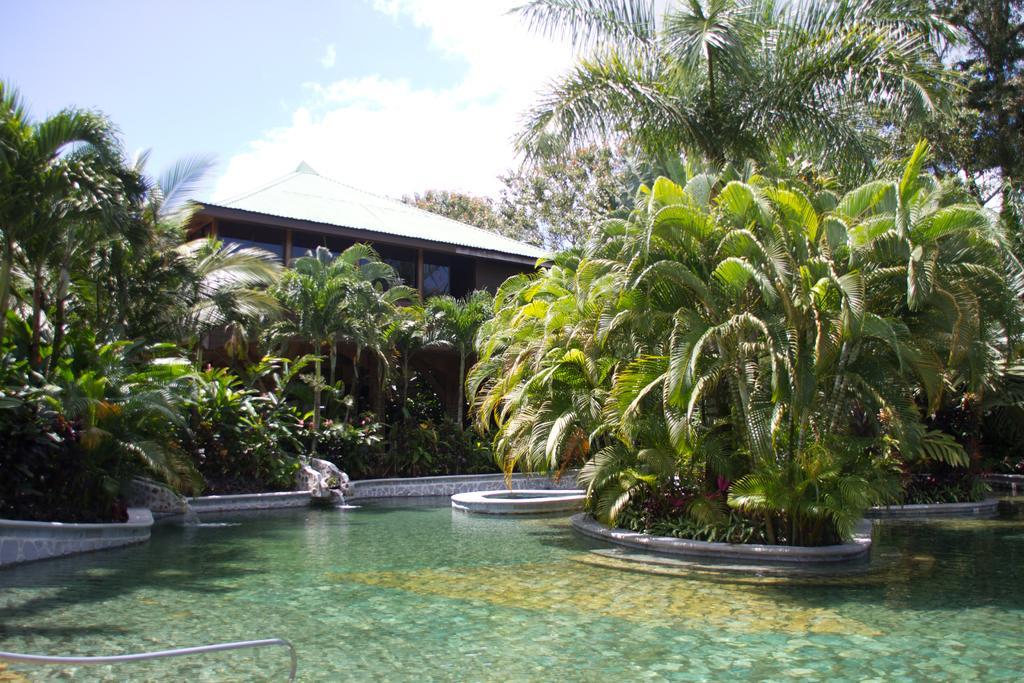Can you describe this image briefly? In this image I can see the water, few trees which are green in color and a building. In the background I can see the sky. 